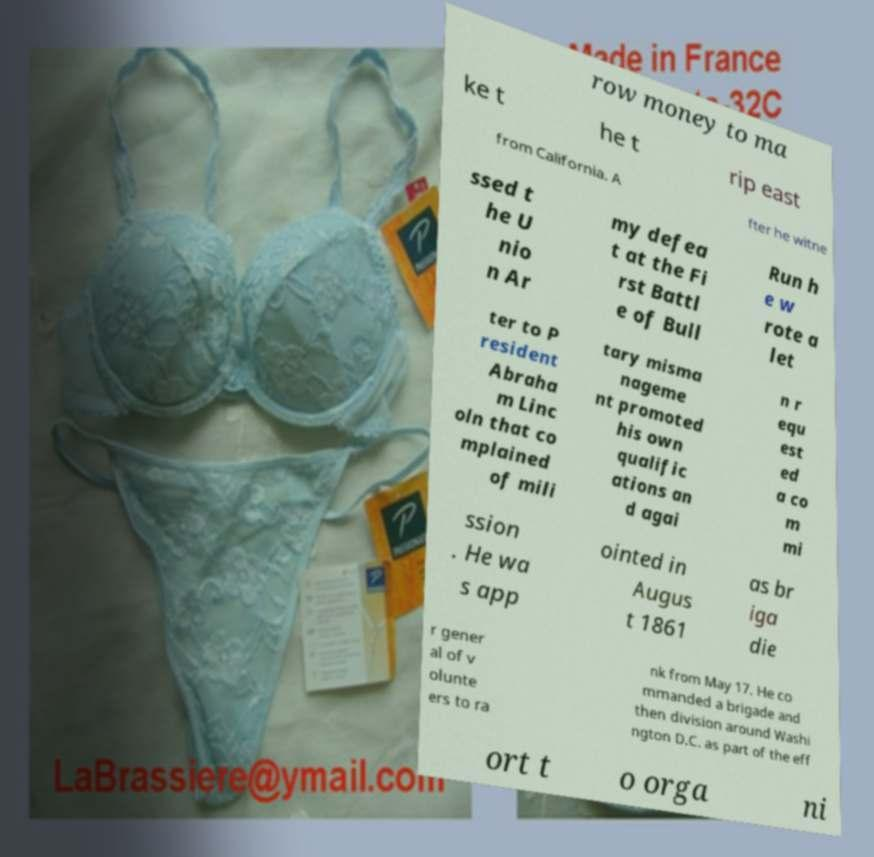I need the written content from this picture converted into text. Can you do that? row money to ma ke t he t rip east from California. A fter he witne ssed t he U nio n Ar my defea t at the Fi rst Battl e of Bull Run h e w rote a let ter to P resident Abraha m Linc oln that co mplained of mili tary misma nageme nt promoted his own qualific ations an d agai n r equ est ed a co m mi ssion . He wa s app ointed in Augus t 1861 as br iga die r gener al of v olunte ers to ra nk from May 17. He co mmanded a brigade and then division around Washi ngton D.C. as part of the eff ort t o orga ni 